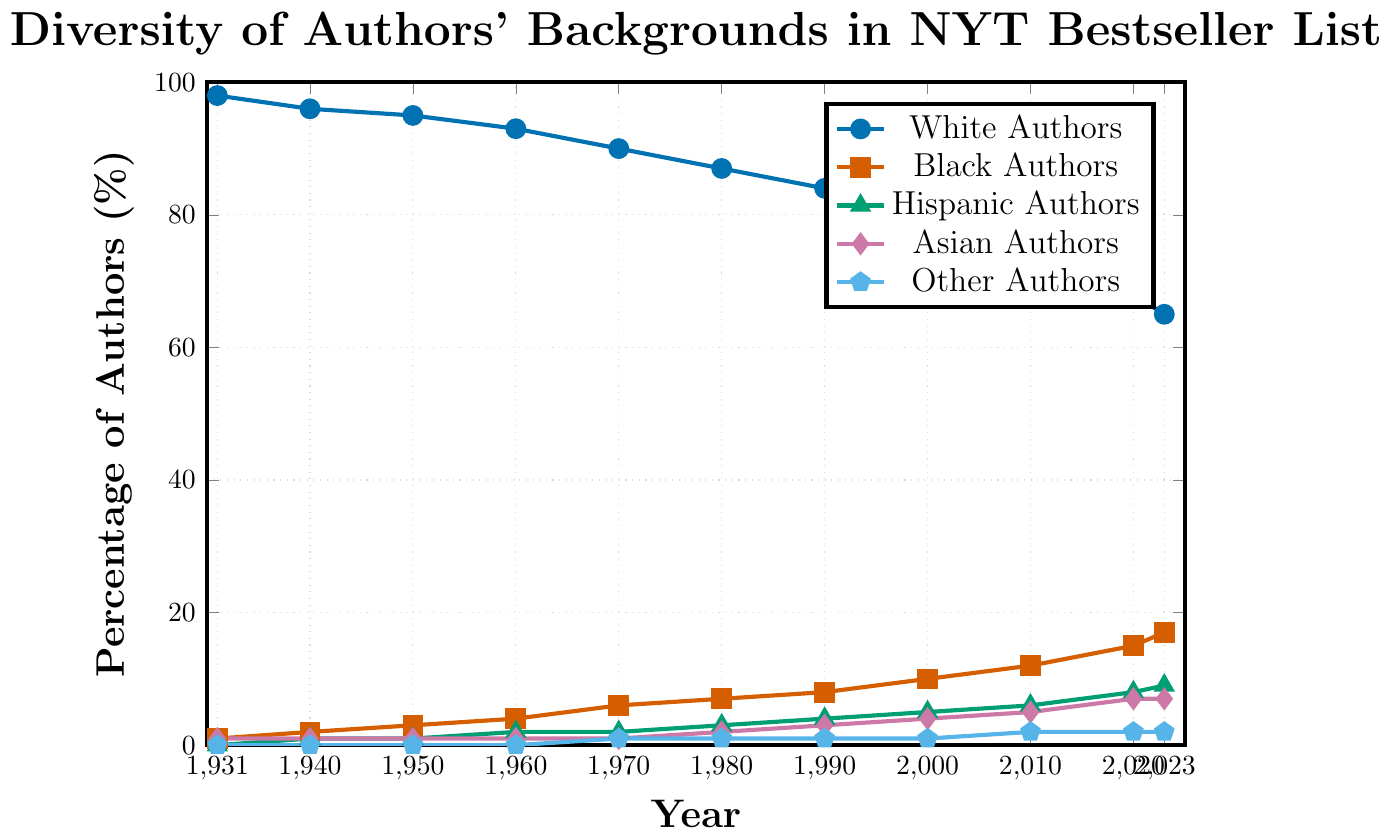What trend do you observe in the percentage of White authors from 1931 to 2023? The percentage of White authors decreases steadily over time. In 1931, it was 98%, and by 2023, it drops to 65%.
Answer: Decreasing Which group has seen the largest increase in representation from 1931 to 2023? To determine this, subtract the 1931 values from the 2023 values for each group. The increases are White: -33%, Black: +16%, Hispanic: +9%, Asian: +6%, Other: +2%. The largest increase is seen in Black authors.
Answer: Black Authors In what year do Black authors first represent more than 10% of the authors on the list? Refer to the data points in the plot for Black authors. The percentage surpasses 10% in the year 2000.
Answer: 2000 By how much did the percentage of Hispanic authors increase between 1980 and 2020? The percentage of Hispanic authors in 1980 was 3%, and in 2020, it was 8%. The increase is 8% - 3% = 5%.
Answer: 5% Compare the percentage of Asian and Hispanic authors in 1990. Which group had a higher percentage and by how much? In 1990, Asian authors were at 3%, while Hispanic authors were at 4%. Hispanic authors had a higher percentage by 1%.
Answer: Hispanic authors by 1% What is the percentage change in the representation of all non-White authors combined from 1931 to 2023? First, calculate the total percentage of non-White authors for both years. In 1931, it's 2% (Black + Asian), and in 2023, it's 35% (100% - 65% White). The change is 35% - 2% = 33%.
Answer: 33% Which author group has the most stable representation over the years and how do you define "most stable"? The percentage of Other authors changes the least over the years: 0% in 1931 to 2% in 2023. The "most stable" representation means the smallest overall change.
Answer: Other authors What is the average percentage representation of Asian authors across all the years shown? Sum all the percentages of Asian authors across the years and divide by the number of years (11): (1+1+1+1+1+2+3+4+5+7+7) / 11 = 33 / 11 = 3%.
Answer: 3% How did the overall percentage of non-White authors change from 2010 to 2023? In 2010, non-White authors accounted for 25% (100% - 75% White). In 2023, non-White authors account for 35% (100% - 65% White). The change is 35% - 25% = 10%.
Answer: 10% What can be inferred about the diversity trend of authors represented on the bestseller list from 1931 to 2023? The marked increase in non-White author percentages and the decrease in White author percentages suggest an increasing diversity among authors on the list.
Answer: Increasing diversity 